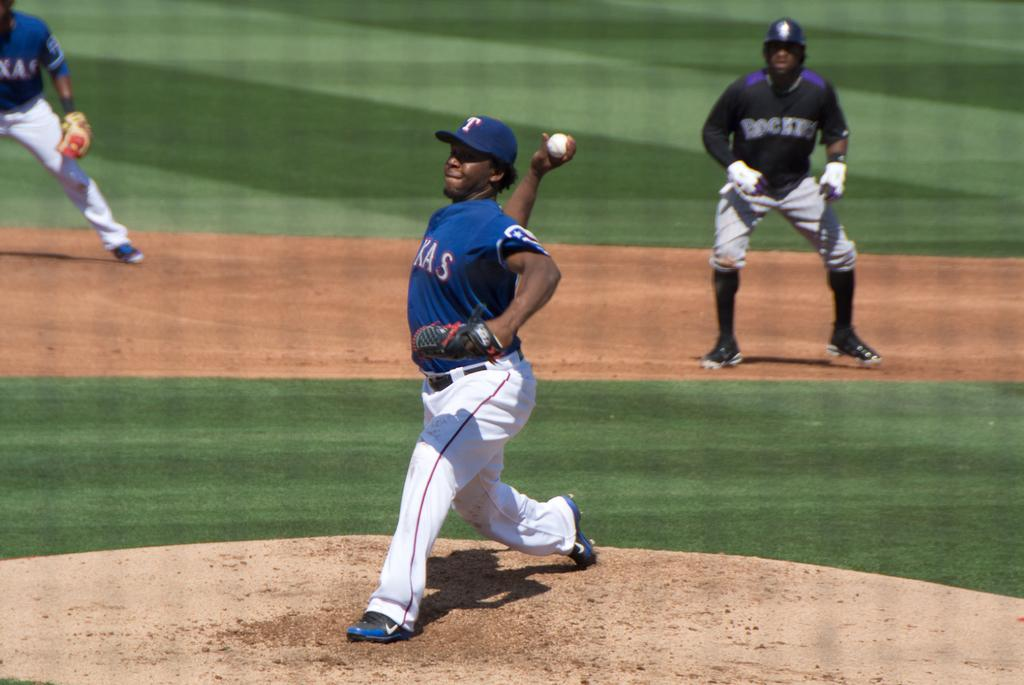<image>
Write a terse but informative summary of the picture. a baseball game going on, the pitcher has a T on his cap. 